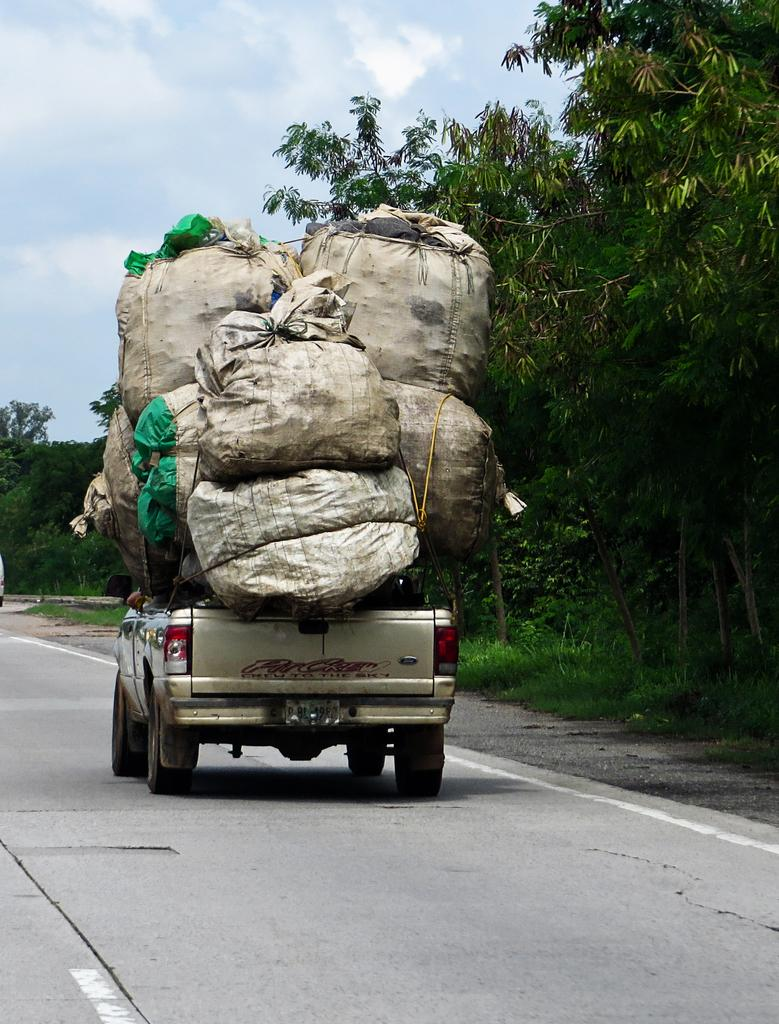What is the main feature of the image? There is a road in the image. What is on the road? There is a vehicle on the road. What can be observed on the vehicle? The vehicle has many bags on it. What type of natural environment is visible in the image? There is grass and trees visible in the image. What is visible in the background of the image? The sky is visible in the background of the image. How many pairs of scissors are lying on the grass in the image? There are no scissors visible in the image; only the road, vehicle, bags, grass, trees, and sky are present. What type of roll is being used to transport the bags on the vehicle? There is no roll visible in the image; the bags are simply placed on the vehicle. 